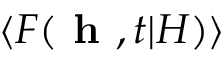Convert formula to latex. <formula><loc_0><loc_0><loc_500><loc_500>\langle F ( h , t | H ) \rangle</formula> 